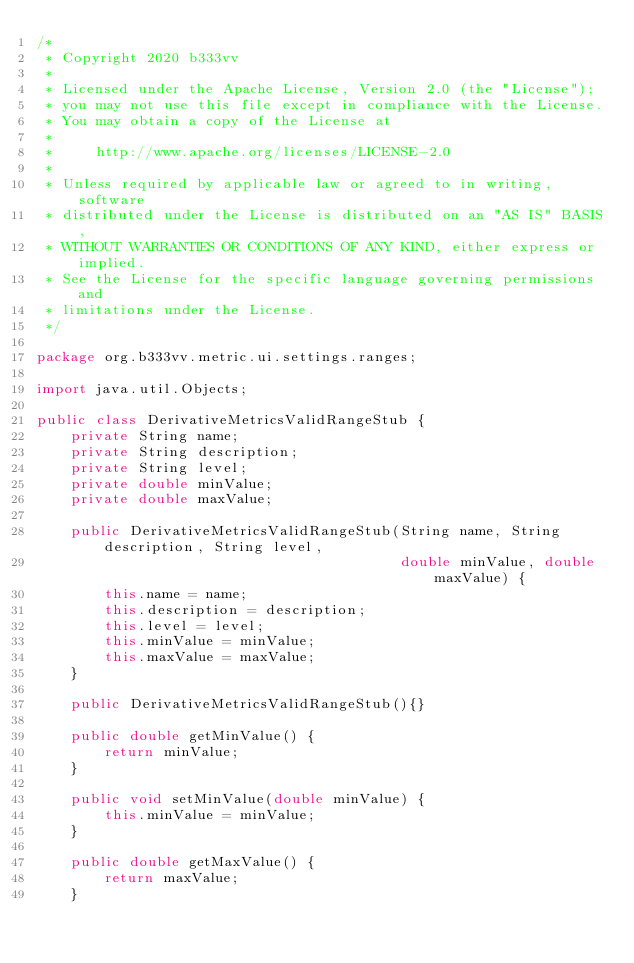<code> <loc_0><loc_0><loc_500><loc_500><_Java_>/*
 * Copyright 2020 b333vv
 *
 * Licensed under the Apache License, Version 2.0 (the "License");
 * you may not use this file except in compliance with the License.
 * You may obtain a copy of the License at
 *
 *     http://www.apache.org/licenses/LICENSE-2.0
 *
 * Unless required by applicable law or agreed to in writing, software
 * distributed under the License is distributed on an "AS IS" BASIS,
 * WITHOUT WARRANTIES OR CONDITIONS OF ANY KIND, either express or implied.
 * See the License for the specific language governing permissions and
 * limitations under the License.
 */

package org.b333vv.metric.ui.settings.ranges;

import java.util.Objects;

public class DerivativeMetricsValidRangeStub {
    private String name;
    private String description;
    private String level;
    private double minValue;
    private double maxValue;

    public DerivativeMetricsValidRangeStub(String name, String description, String level,
                                           double minValue, double maxValue) {
        this.name = name;
        this.description = description;
        this.level = level;
        this.minValue = minValue;
        this.maxValue = maxValue;
    }

    public DerivativeMetricsValidRangeStub(){}

    public double getMinValue() {
        return minValue;
    }

    public void setMinValue(double minValue) {
        this.minValue = minValue;
    }

    public double getMaxValue() {
        return maxValue;
    }
</code> 